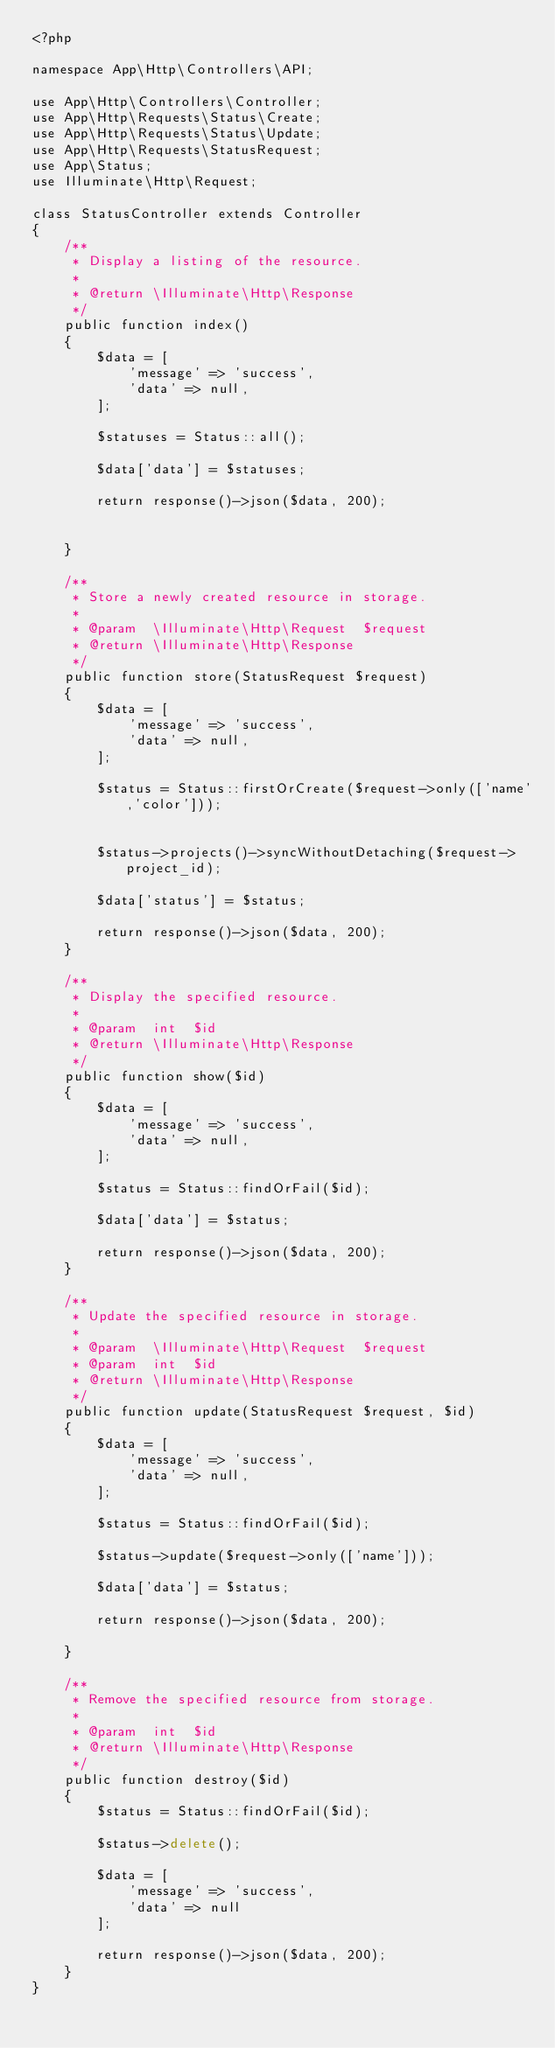<code> <loc_0><loc_0><loc_500><loc_500><_PHP_><?php

namespace App\Http\Controllers\API;

use App\Http\Controllers\Controller;
use App\Http\Requests\Status\Create;
use App\Http\Requests\Status\Update;
use App\Http\Requests\StatusRequest;
use App\Status;
use Illuminate\Http\Request;

class StatusController extends Controller
{
    /**
     * Display a listing of the resource.
     *
     * @return \Illuminate\Http\Response
     */
    public function index()
    {
        $data = [
            'message' => 'success',
            'data' => null,
        ];

        $statuses = Status::all();

        $data['data'] = $statuses;

        return response()->json($data, 200);


    }

    /**
     * Store a newly created resource in storage.
     *
     * @param  \Illuminate\Http\Request  $request
     * @return \Illuminate\Http\Response
     */
    public function store(StatusRequest $request)
    {
        $data = [
            'message' => 'success',
            'data' => null,
        ];

        $status = Status::firstOrCreate($request->only(['name','color']));


        $status->projects()->syncWithoutDetaching($request->project_id);

        $data['status'] = $status;

        return response()->json($data, 200);
    }

    /**
     * Display the specified resource.
     *
     * @param  int  $id
     * @return \Illuminate\Http\Response
     */
    public function show($id)
    {
        $data = [
            'message' => 'success',
            'data' => null,
        ];

        $status = Status::findOrFail($id);

        $data['data'] = $status;

        return response()->json($data, 200);
    }

    /**
     * Update the specified resource in storage.
     *
     * @param  \Illuminate\Http\Request  $request
     * @param  int  $id
     * @return \Illuminate\Http\Response
     */
    public function update(StatusRequest $request, $id)
    {
        $data = [
            'message' => 'success',
            'data' => null,
        ];

        $status = Status::findOrFail($id);

        $status->update($request->only(['name']));

        $data['data'] = $status;

        return response()->json($data, 200);

    }

    /**
     * Remove the specified resource from storage.
     *
     * @param  int  $id
     * @return \Illuminate\Http\Response
     */
    public function destroy($id)
    {
        $status = Status::findOrFail($id);

        $status->delete();

        $data = [
            'message' => 'success',
            'data' => null
        ];

        return response()->json($data, 200);
    }
}
</code> 